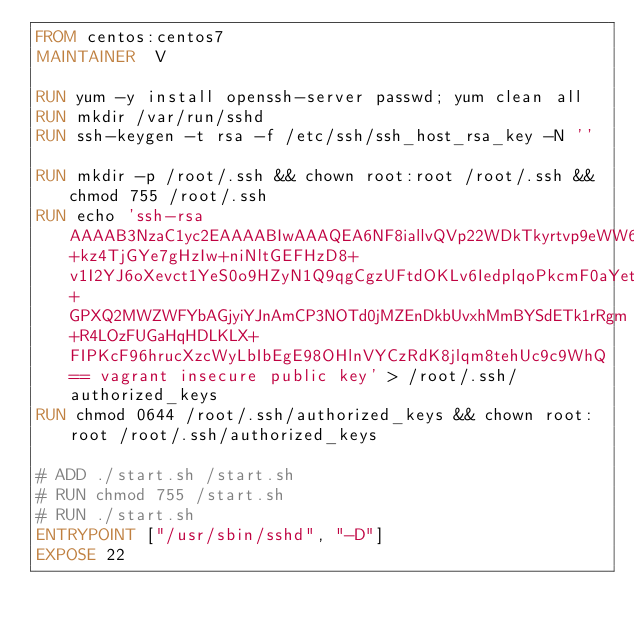Convert code to text. <code><loc_0><loc_0><loc_500><loc_500><_Dockerfile_>FROM centos:centos7
MAINTAINER  V

RUN yum -y install openssh-server passwd; yum clean all
RUN mkdir /var/run/sshd
RUN ssh-keygen -t rsa -f /etc/ssh/ssh_host_rsa_key -N ''

RUN mkdir -p /root/.ssh && chown root:root /root/.ssh && chmod 755 /root/.ssh
RUN echo 'ssh-rsa AAAAB3NzaC1yc2EAAAABIwAAAQEA6NF8iallvQVp22WDkTkyrtvp9eWW6A8YVr+kz4TjGYe7gHzIw+niNltGEFHzD8+v1I2YJ6oXevct1YeS0o9HZyN1Q9qgCgzUFtdOKLv6IedplqoPkcmF0aYet2PkEDo3MlTBckFXPITAMzF8dJSIFo9D8HfdOV0IAdx4O7PtixWKn5y2hMNG0zQPyUecp4pzC6kivAIhyfHilFR61RGL+GPXQ2MWZWFYbAGjyiYJnAmCP3NOTd0jMZEnDkbUvxhMmBYSdETk1rRgm+R4LOzFUGaHqHDLKLX+FIPKcF96hrucXzcWyLbIbEgE98OHlnVYCzRdK8jlqm8tehUc9c9WhQ== vagrant insecure public key' > /root/.ssh/authorized_keys
RUN chmod 0644 /root/.ssh/authorized_keys && chown root:root /root/.ssh/authorized_keys

# ADD ./start.sh /start.sh
# RUN chmod 755 /start.sh
# RUN ./start.sh
ENTRYPOINT ["/usr/sbin/sshd", "-D"]
EXPOSE 22
</code> 